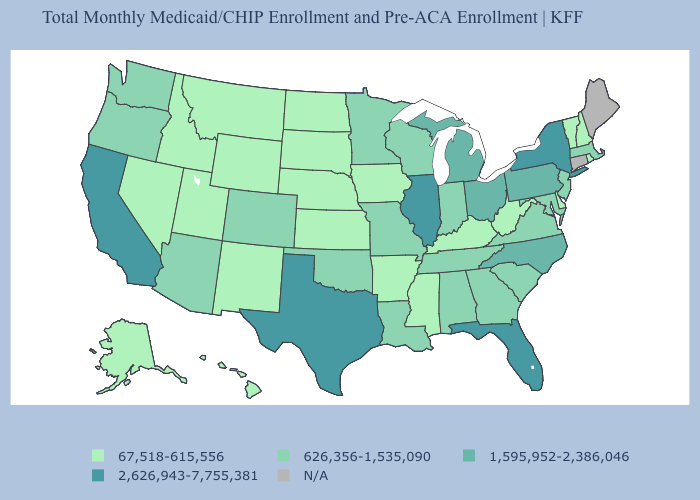What is the value of Arkansas?
Give a very brief answer. 67,518-615,556. What is the value of Kentucky?
Concise answer only. 67,518-615,556. What is the lowest value in states that border West Virginia?
Quick response, please. 67,518-615,556. Which states have the highest value in the USA?
Concise answer only. California, Florida, Illinois, New York, Texas. Does the map have missing data?
Short answer required. Yes. Does Illinois have the highest value in the USA?
Concise answer only. Yes. Which states hav the highest value in the MidWest?
Short answer required. Illinois. Is the legend a continuous bar?
Be succinct. No. Among the states that border Tennessee , which have the highest value?
Concise answer only. North Carolina. Among the states that border Delaware , which have the lowest value?
Be succinct. Maryland, New Jersey. Name the states that have a value in the range 1,595,952-2,386,046?
Give a very brief answer. Michigan, North Carolina, Ohio, Pennsylvania. Does the map have missing data?
Answer briefly. Yes. What is the value of New York?
Give a very brief answer. 2,626,943-7,755,381. Does California have the highest value in the West?
Be succinct. Yes. 